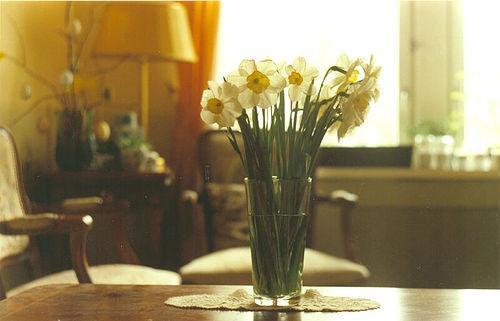How many chairs are depicted?
Give a very brief answer. 2. What kind of flower is in the vase?
Answer briefly. Daffodil. Is the vase on top of a crocheted cover?
Write a very short answer. Yes. 